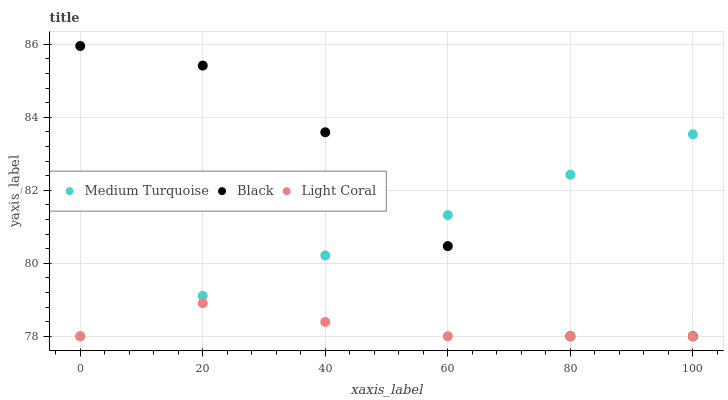Does Light Coral have the minimum area under the curve?
Answer yes or no. Yes. Does Black have the maximum area under the curve?
Answer yes or no. Yes. Does Medium Turquoise have the minimum area under the curve?
Answer yes or no. No. Does Medium Turquoise have the maximum area under the curve?
Answer yes or no. No. Is Medium Turquoise the smoothest?
Answer yes or no. Yes. Is Black the roughest?
Answer yes or no. Yes. Is Black the smoothest?
Answer yes or no. No. Is Medium Turquoise the roughest?
Answer yes or no. No. Does Light Coral have the lowest value?
Answer yes or no. Yes. Does Black have the highest value?
Answer yes or no. Yes. Does Medium Turquoise have the highest value?
Answer yes or no. No. Does Medium Turquoise intersect Light Coral?
Answer yes or no. Yes. Is Medium Turquoise less than Light Coral?
Answer yes or no. No. Is Medium Turquoise greater than Light Coral?
Answer yes or no. No. 